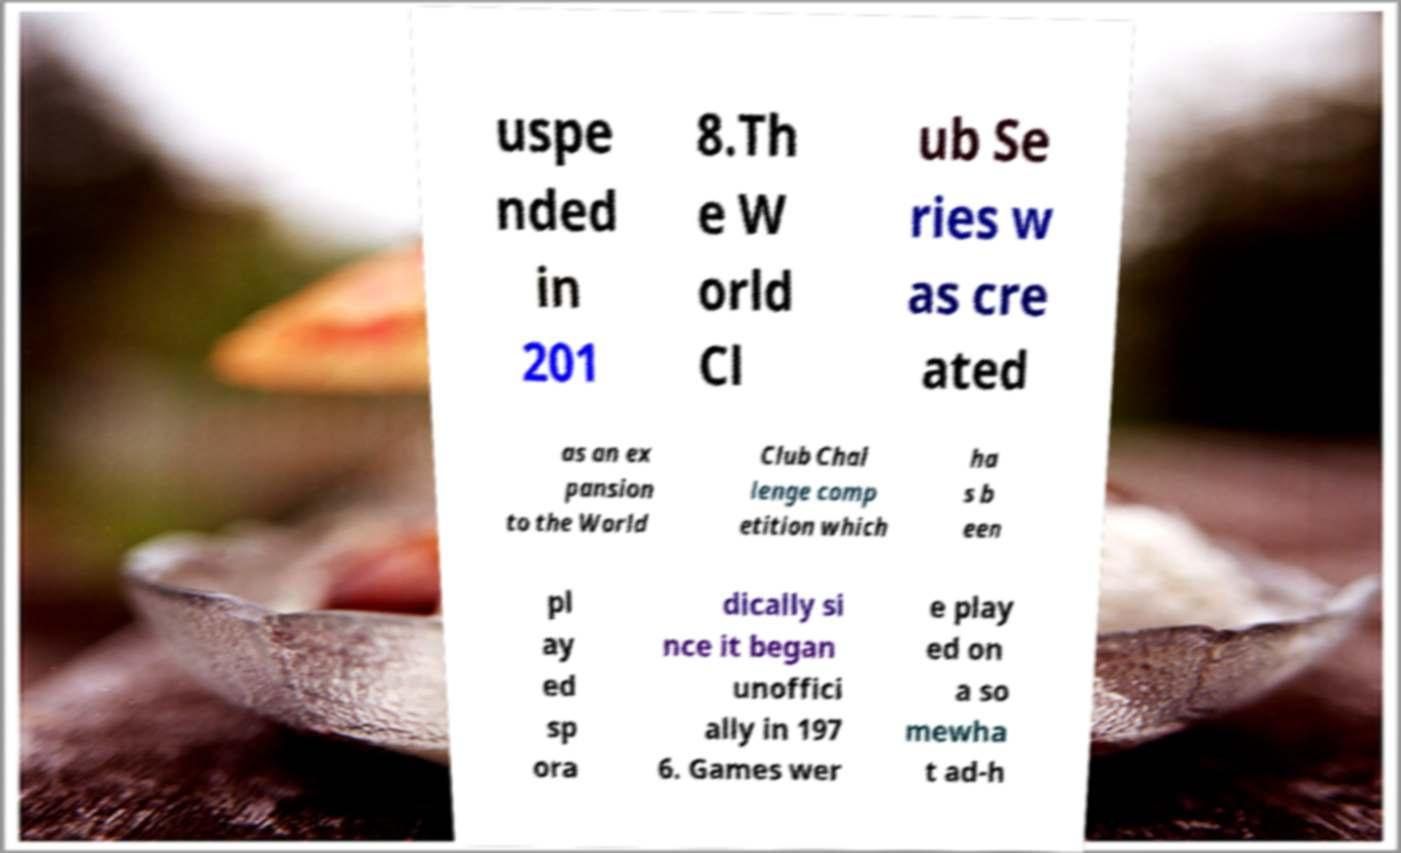Can you read and provide the text displayed in the image?This photo seems to have some interesting text. Can you extract and type it out for me? uspe nded in 201 8.Th e W orld Cl ub Se ries w as cre ated as an ex pansion to the World Club Chal lenge comp etition which ha s b een pl ay ed sp ora dically si nce it began unoffici ally in 197 6. Games wer e play ed on a so mewha t ad-h 